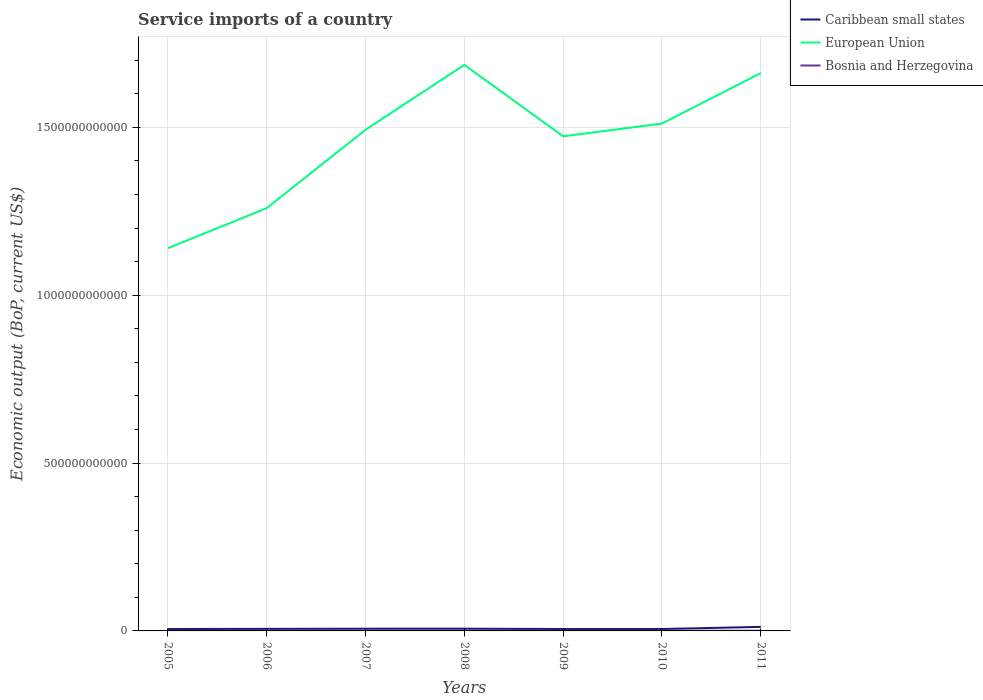How many different coloured lines are there?
Offer a very short reply. 3. Does the line corresponding to European Union intersect with the line corresponding to Caribbean small states?
Your answer should be very brief. No. Across all years, what is the maximum service imports in Caribbean small states?
Ensure brevity in your answer.  5.64e+09. In which year was the service imports in Caribbean small states maximum?
Make the answer very short. 2005. What is the total service imports in Caribbean small states in the graph?
Provide a short and direct response. -9.07e+08. What is the difference between the highest and the second highest service imports in Caribbean small states?
Your answer should be very brief. 6.39e+09. What is the difference between the highest and the lowest service imports in Caribbean small states?
Offer a terse response. 1. What is the difference between two consecutive major ticks on the Y-axis?
Give a very brief answer. 5.00e+11. Are the values on the major ticks of Y-axis written in scientific E-notation?
Offer a very short reply. No. Does the graph contain any zero values?
Your answer should be compact. No. Does the graph contain grids?
Your answer should be very brief. Yes. Where does the legend appear in the graph?
Offer a very short reply. Top right. How are the legend labels stacked?
Offer a terse response. Vertical. What is the title of the graph?
Give a very brief answer. Service imports of a country. What is the label or title of the X-axis?
Give a very brief answer. Years. What is the label or title of the Y-axis?
Your answer should be very brief. Economic output (BoP, current US$). What is the Economic output (BoP, current US$) of Caribbean small states in 2005?
Provide a succinct answer. 5.64e+09. What is the Economic output (BoP, current US$) in European Union in 2005?
Keep it short and to the point. 1.14e+12. What is the Economic output (BoP, current US$) in Bosnia and Herzegovina in 2005?
Offer a terse response. 4.36e+08. What is the Economic output (BoP, current US$) in Caribbean small states in 2006?
Make the answer very short. 6.14e+09. What is the Economic output (BoP, current US$) in European Union in 2006?
Give a very brief answer. 1.26e+12. What is the Economic output (BoP, current US$) of Bosnia and Herzegovina in 2006?
Make the answer very short. 4.67e+08. What is the Economic output (BoP, current US$) in Caribbean small states in 2007?
Your answer should be compact. 6.55e+09. What is the Economic output (BoP, current US$) of European Union in 2007?
Make the answer very short. 1.49e+12. What is the Economic output (BoP, current US$) of Bosnia and Herzegovina in 2007?
Give a very brief answer. 4.95e+08. What is the Economic output (BoP, current US$) of Caribbean small states in 2008?
Offer a terse response. 6.66e+09. What is the Economic output (BoP, current US$) in European Union in 2008?
Give a very brief answer. 1.69e+12. What is the Economic output (BoP, current US$) in Bosnia and Herzegovina in 2008?
Provide a succinct answer. 5.95e+08. What is the Economic output (BoP, current US$) of Caribbean small states in 2009?
Make the answer very short. 5.67e+09. What is the Economic output (BoP, current US$) in European Union in 2009?
Provide a succinct answer. 1.47e+12. What is the Economic output (BoP, current US$) of Bosnia and Herzegovina in 2009?
Make the answer very short. 6.40e+08. What is the Economic output (BoP, current US$) of Caribbean small states in 2010?
Keep it short and to the point. 5.69e+09. What is the Economic output (BoP, current US$) in European Union in 2010?
Offer a terse response. 1.51e+12. What is the Economic output (BoP, current US$) of Bosnia and Herzegovina in 2010?
Keep it short and to the point. 5.41e+08. What is the Economic output (BoP, current US$) of Caribbean small states in 2011?
Make the answer very short. 1.20e+1. What is the Economic output (BoP, current US$) of European Union in 2011?
Make the answer very short. 1.66e+12. What is the Economic output (BoP, current US$) in Bosnia and Herzegovina in 2011?
Give a very brief answer. 5.57e+08. Across all years, what is the maximum Economic output (BoP, current US$) in Caribbean small states?
Your response must be concise. 1.20e+1. Across all years, what is the maximum Economic output (BoP, current US$) of European Union?
Keep it short and to the point. 1.69e+12. Across all years, what is the maximum Economic output (BoP, current US$) of Bosnia and Herzegovina?
Offer a very short reply. 6.40e+08. Across all years, what is the minimum Economic output (BoP, current US$) of Caribbean small states?
Provide a succinct answer. 5.64e+09. Across all years, what is the minimum Economic output (BoP, current US$) in European Union?
Your answer should be very brief. 1.14e+12. Across all years, what is the minimum Economic output (BoP, current US$) in Bosnia and Herzegovina?
Give a very brief answer. 4.36e+08. What is the total Economic output (BoP, current US$) of Caribbean small states in the graph?
Your response must be concise. 4.84e+1. What is the total Economic output (BoP, current US$) in European Union in the graph?
Offer a terse response. 1.02e+13. What is the total Economic output (BoP, current US$) of Bosnia and Herzegovina in the graph?
Make the answer very short. 3.73e+09. What is the difference between the Economic output (BoP, current US$) of Caribbean small states in 2005 and that in 2006?
Offer a terse response. -5.00e+08. What is the difference between the Economic output (BoP, current US$) of European Union in 2005 and that in 2006?
Give a very brief answer. -1.19e+11. What is the difference between the Economic output (BoP, current US$) of Bosnia and Herzegovina in 2005 and that in 2006?
Give a very brief answer. -3.12e+07. What is the difference between the Economic output (BoP, current US$) in Caribbean small states in 2005 and that in 2007?
Give a very brief answer. -9.07e+08. What is the difference between the Economic output (BoP, current US$) of European Union in 2005 and that in 2007?
Ensure brevity in your answer.  -3.53e+11. What is the difference between the Economic output (BoP, current US$) of Bosnia and Herzegovina in 2005 and that in 2007?
Offer a terse response. -5.97e+07. What is the difference between the Economic output (BoP, current US$) of Caribbean small states in 2005 and that in 2008?
Provide a succinct answer. -1.02e+09. What is the difference between the Economic output (BoP, current US$) of European Union in 2005 and that in 2008?
Provide a short and direct response. -5.46e+11. What is the difference between the Economic output (BoP, current US$) in Bosnia and Herzegovina in 2005 and that in 2008?
Offer a terse response. -1.59e+08. What is the difference between the Economic output (BoP, current US$) in Caribbean small states in 2005 and that in 2009?
Offer a very short reply. -2.25e+07. What is the difference between the Economic output (BoP, current US$) of European Union in 2005 and that in 2009?
Give a very brief answer. -3.33e+11. What is the difference between the Economic output (BoP, current US$) of Bosnia and Herzegovina in 2005 and that in 2009?
Give a very brief answer. -2.05e+08. What is the difference between the Economic output (BoP, current US$) of Caribbean small states in 2005 and that in 2010?
Offer a terse response. -4.30e+07. What is the difference between the Economic output (BoP, current US$) in European Union in 2005 and that in 2010?
Your answer should be compact. -3.71e+11. What is the difference between the Economic output (BoP, current US$) in Bosnia and Herzegovina in 2005 and that in 2010?
Make the answer very short. -1.05e+08. What is the difference between the Economic output (BoP, current US$) of Caribbean small states in 2005 and that in 2011?
Offer a very short reply. -6.39e+09. What is the difference between the Economic output (BoP, current US$) of European Union in 2005 and that in 2011?
Provide a short and direct response. -5.22e+11. What is the difference between the Economic output (BoP, current US$) of Bosnia and Herzegovina in 2005 and that in 2011?
Make the answer very short. -1.22e+08. What is the difference between the Economic output (BoP, current US$) in Caribbean small states in 2006 and that in 2007?
Give a very brief answer. -4.07e+08. What is the difference between the Economic output (BoP, current US$) in European Union in 2006 and that in 2007?
Make the answer very short. -2.33e+11. What is the difference between the Economic output (BoP, current US$) in Bosnia and Herzegovina in 2006 and that in 2007?
Keep it short and to the point. -2.86e+07. What is the difference between the Economic output (BoP, current US$) of Caribbean small states in 2006 and that in 2008?
Make the answer very short. -5.19e+08. What is the difference between the Economic output (BoP, current US$) of European Union in 2006 and that in 2008?
Keep it short and to the point. -4.27e+11. What is the difference between the Economic output (BoP, current US$) in Bosnia and Herzegovina in 2006 and that in 2008?
Your response must be concise. -1.28e+08. What is the difference between the Economic output (BoP, current US$) in Caribbean small states in 2006 and that in 2009?
Keep it short and to the point. 4.78e+08. What is the difference between the Economic output (BoP, current US$) of European Union in 2006 and that in 2009?
Make the answer very short. -2.14e+11. What is the difference between the Economic output (BoP, current US$) in Bosnia and Herzegovina in 2006 and that in 2009?
Ensure brevity in your answer.  -1.74e+08. What is the difference between the Economic output (BoP, current US$) in Caribbean small states in 2006 and that in 2010?
Make the answer very short. 4.57e+08. What is the difference between the Economic output (BoP, current US$) in European Union in 2006 and that in 2010?
Provide a succinct answer. -2.52e+11. What is the difference between the Economic output (BoP, current US$) of Bosnia and Herzegovina in 2006 and that in 2010?
Offer a terse response. -7.42e+07. What is the difference between the Economic output (BoP, current US$) in Caribbean small states in 2006 and that in 2011?
Your answer should be very brief. -5.89e+09. What is the difference between the Economic output (BoP, current US$) in European Union in 2006 and that in 2011?
Offer a very short reply. -4.02e+11. What is the difference between the Economic output (BoP, current US$) of Bosnia and Herzegovina in 2006 and that in 2011?
Your answer should be very brief. -9.05e+07. What is the difference between the Economic output (BoP, current US$) in Caribbean small states in 2007 and that in 2008?
Give a very brief answer. -1.12e+08. What is the difference between the Economic output (BoP, current US$) of European Union in 2007 and that in 2008?
Your answer should be very brief. -1.93e+11. What is the difference between the Economic output (BoP, current US$) of Bosnia and Herzegovina in 2007 and that in 2008?
Offer a very short reply. -9.97e+07. What is the difference between the Economic output (BoP, current US$) of Caribbean small states in 2007 and that in 2009?
Make the answer very short. 8.85e+08. What is the difference between the Economic output (BoP, current US$) in European Union in 2007 and that in 2009?
Your answer should be compact. 1.95e+1. What is the difference between the Economic output (BoP, current US$) in Bosnia and Herzegovina in 2007 and that in 2009?
Your answer should be very brief. -1.45e+08. What is the difference between the Economic output (BoP, current US$) of Caribbean small states in 2007 and that in 2010?
Provide a succinct answer. 8.64e+08. What is the difference between the Economic output (BoP, current US$) in European Union in 2007 and that in 2010?
Your answer should be compact. -1.86e+1. What is the difference between the Economic output (BoP, current US$) in Bosnia and Herzegovina in 2007 and that in 2010?
Provide a succinct answer. -4.56e+07. What is the difference between the Economic output (BoP, current US$) of Caribbean small states in 2007 and that in 2011?
Offer a very short reply. -5.48e+09. What is the difference between the Economic output (BoP, current US$) of European Union in 2007 and that in 2011?
Provide a succinct answer. -1.69e+11. What is the difference between the Economic output (BoP, current US$) of Bosnia and Herzegovina in 2007 and that in 2011?
Give a very brief answer. -6.19e+07. What is the difference between the Economic output (BoP, current US$) in Caribbean small states in 2008 and that in 2009?
Offer a terse response. 9.96e+08. What is the difference between the Economic output (BoP, current US$) in European Union in 2008 and that in 2009?
Ensure brevity in your answer.  2.13e+11. What is the difference between the Economic output (BoP, current US$) of Bosnia and Herzegovina in 2008 and that in 2009?
Offer a very short reply. -4.55e+07. What is the difference between the Economic output (BoP, current US$) of Caribbean small states in 2008 and that in 2010?
Provide a succinct answer. 9.76e+08. What is the difference between the Economic output (BoP, current US$) in European Union in 2008 and that in 2010?
Offer a terse response. 1.75e+11. What is the difference between the Economic output (BoP, current US$) of Bosnia and Herzegovina in 2008 and that in 2010?
Ensure brevity in your answer.  5.40e+07. What is the difference between the Economic output (BoP, current US$) in Caribbean small states in 2008 and that in 2011?
Your answer should be compact. -5.37e+09. What is the difference between the Economic output (BoP, current US$) of European Union in 2008 and that in 2011?
Keep it short and to the point. 2.44e+1. What is the difference between the Economic output (BoP, current US$) of Bosnia and Herzegovina in 2008 and that in 2011?
Ensure brevity in your answer.  3.77e+07. What is the difference between the Economic output (BoP, current US$) of Caribbean small states in 2009 and that in 2010?
Offer a very short reply. -2.06e+07. What is the difference between the Economic output (BoP, current US$) of European Union in 2009 and that in 2010?
Provide a short and direct response. -3.81e+1. What is the difference between the Economic output (BoP, current US$) of Bosnia and Herzegovina in 2009 and that in 2010?
Keep it short and to the point. 9.95e+07. What is the difference between the Economic output (BoP, current US$) in Caribbean small states in 2009 and that in 2011?
Ensure brevity in your answer.  -6.37e+09. What is the difference between the Economic output (BoP, current US$) in European Union in 2009 and that in 2011?
Offer a very short reply. -1.88e+11. What is the difference between the Economic output (BoP, current US$) in Bosnia and Herzegovina in 2009 and that in 2011?
Your response must be concise. 8.32e+07. What is the difference between the Economic output (BoP, current US$) of Caribbean small states in 2010 and that in 2011?
Provide a short and direct response. -6.35e+09. What is the difference between the Economic output (BoP, current US$) of European Union in 2010 and that in 2011?
Give a very brief answer. -1.50e+11. What is the difference between the Economic output (BoP, current US$) of Bosnia and Herzegovina in 2010 and that in 2011?
Your response must be concise. -1.63e+07. What is the difference between the Economic output (BoP, current US$) in Caribbean small states in 2005 and the Economic output (BoP, current US$) in European Union in 2006?
Give a very brief answer. -1.25e+12. What is the difference between the Economic output (BoP, current US$) of Caribbean small states in 2005 and the Economic output (BoP, current US$) of Bosnia and Herzegovina in 2006?
Keep it short and to the point. 5.18e+09. What is the difference between the Economic output (BoP, current US$) in European Union in 2005 and the Economic output (BoP, current US$) in Bosnia and Herzegovina in 2006?
Offer a very short reply. 1.14e+12. What is the difference between the Economic output (BoP, current US$) of Caribbean small states in 2005 and the Economic output (BoP, current US$) of European Union in 2007?
Offer a terse response. -1.49e+12. What is the difference between the Economic output (BoP, current US$) of Caribbean small states in 2005 and the Economic output (BoP, current US$) of Bosnia and Herzegovina in 2007?
Ensure brevity in your answer.  5.15e+09. What is the difference between the Economic output (BoP, current US$) of European Union in 2005 and the Economic output (BoP, current US$) of Bosnia and Herzegovina in 2007?
Provide a short and direct response. 1.14e+12. What is the difference between the Economic output (BoP, current US$) of Caribbean small states in 2005 and the Economic output (BoP, current US$) of European Union in 2008?
Offer a terse response. -1.68e+12. What is the difference between the Economic output (BoP, current US$) of Caribbean small states in 2005 and the Economic output (BoP, current US$) of Bosnia and Herzegovina in 2008?
Keep it short and to the point. 5.05e+09. What is the difference between the Economic output (BoP, current US$) of European Union in 2005 and the Economic output (BoP, current US$) of Bosnia and Herzegovina in 2008?
Offer a very short reply. 1.14e+12. What is the difference between the Economic output (BoP, current US$) of Caribbean small states in 2005 and the Economic output (BoP, current US$) of European Union in 2009?
Your answer should be compact. -1.47e+12. What is the difference between the Economic output (BoP, current US$) in Caribbean small states in 2005 and the Economic output (BoP, current US$) in Bosnia and Herzegovina in 2009?
Provide a succinct answer. 5.00e+09. What is the difference between the Economic output (BoP, current US$) of European Union in 2005 and the Economic output (BoP, current US$) of Bosnia and Herzegovina in 2009?
Your answer should be compact. 1.14e+12. What is the difference between the Economic output (BoP, current US$) of Caribbean small states in 2005 and the Economic output (BoP, current US$) of European Union in 2010?
Ensure brevity in your answer.  -1.51e+12. What is the difference between the Economic output (BoP, current US$) in Caribbean small states in 2005 and the Economic output (BoP, current US$) in Bosnia and Herzegovina in 2010?
Keep it short and to the point. 5.10e+09. What is the difference between the Economic output (BoP, current US$) in European Union in 2005 and the Economic output (BoP, current US$) in Bosnia and Herzegovina in 2010?
Provide a succinct answer. 1.14e+12. What is the difference between the Economic output (BoP, current US$) in Caribbean small states in 2005 and the Economic output (BoP, current US$) in European Union in 2011?
Offer a very short reply. -1.66e+12. What is the difference between the Economic output (BoP, current US$) in Caribbean small states in 2005 and the Economic output (BoP, current US$) in Bosnia and Herzegovina in 2011?
Provide a succinct answer. 5.09e+09. What is the difference between the Economic output (BoP, current US$) in European Union in 2005 and the Economic output (BoP, current US$) in Bosnia and Herzegovina in 2011?
Keep it short and to the point. 1.14e+12. What is the difference between the Economic output (BoP, current US$) in Caribbean small states in 2006 and the Economic output (BoP, current US$) in European Union in 2007?
Make the answer very short. -1.49e+12. What is the difference between the Economic output (BoP, current US$) of Caribbean small states in 2006 and the Economic output (BoP, current US$) of Bosnia and Herzegovina in 2007?
Make the answer very short. 5.65e+09. What is the difference between the Economic output (BoP, current US$) of European Union in 2006 and the Economic output (BoP, current US$) of Bosnia and Herzegovina in 2007?
Offer a terse response. 1.26e+12. What is the difference between the Economic output (BoP, current US$) of Caribbean small states in 2006 and the Economic output (BoP, current US$) of European Union in 2008?
Your answer should be very brief. -1.68e+12. What is the difference between the Economic output (BoP, current US$) in Caribbean small states in 2006 and the Economic output (BoP, current US$) in Bosnia and Herzegovina in 2008?
Your response must be concise. 5.55e+09. What is the difference between the Economic output (BoP, current US$) in European Union in 2006 and the Economic output (BoP, current US$) in Bosnia and Herzegovina in 2008?
Provide a short and direct response. 1.26e+12. What is the difference between the Economic output (BoP, current US$) of Caribbean small states in 2006 and the Economic output (BoP, current US$) of European Union in 2009?
Your response must be concise. -1.47e+12. What is the difference between the Economic output (BoP, current US$) of Caribbean small states in 2006 and the Economic output (BoP, current US$) of Bosnia and Herzegovina in 2009?
Make the answer very short. 5.50e+09. What is the difference between the Economic output (BoP, current US$) of European Union in 2006 and the Economic output (BoP, current US$) of Bosnia and Herzegovina in 2009?
Give a very brief answer. 1.26e+12. What is the difference between the Economic output (BoP, current US$) of Caribbean small states in 2006 and the Economic output (BoP, current US$) of European Union in 2010?
Your answer should be very brief. -1.51e+12. What is the difference between the Economic output (BoP, current US$) in Caribbean small states in 2006 and the Economic output (BoP, current US$) in Bosnia and Herzegovina in 2010?
Your response must be concise. 5.60e+09. What is the difference between the Economic output (BoP, current US$) in European Union in 2006 and the Economic output (BoP, current US$) in Bosnia and Herzegovina in 2010?
Your answer should be compact. 1.26e+12. What is the difference between the Economic output (BoP, current US$) of Caribbean small states in 2006 and the Economic output (BoP, current US$) of European Union in 2011?
Provide a short and direct response. -1.66e+12. What is the difference between the Economic output (BoP, current US$) in Caribbean small states in 2006 and the Economic output (BoP, current US$) in Bosnia and Herzegovina in 2011?
Ensure brevity in your answer.  5.59e+09. What is the difference between the Economic output (BoP, current US$) of European Union in 2006 and the Economic output (BoP, current US$) of Bosnia and Herzegovina in 2011?
Offer a terse response. 1.26e+12. What is the difference between the Economic output (BoP, current US$) of Caribbean small states in 2007 and the Economic output (BoP, current US$) of European Union in 2008?
Provide a short and direct response. -1.68e+12. What is the difference between the Economic output (BoP, current US$) in Caribbean small states in 2007 and the Economic output (BoP, current US$) in Bosnia and Herzegovina in 2008?
Your answer should be compact. 5.96e+09. What is the difference between the Economic output (BoP, current US$) of European Union in 2007 and the Economic output (BoP, current US$) of Bosnia and Herzegovina in 2008?
Offer a very short reply. 1.49e+12. What is the difference between the Economic output (BoP, current US$) of Caribbean small states in 2007 and the Economic output (BoP, current US$) of European Union in 2009?
Offer a terse response. -1.47e+12. What is the difference between the Economic output (BoP, current US$) of Caribbean small states in 2007 and the Economic output (BoP, current US$) of Bosnia and Herzegovina in 2009?
Keep it short and to the point. 5.91e+09. What is the difference between the Economic output (BoP, current US$) in European Union in 2007 and the Economic output (BoP, current US$) in Bosnia and Herzegovina in 2009?
Keep it short and to the point. 1.49e+12. What is the difference between the Economic output (BoP, current US$) of Caribbean small states in 2007 and the Economic output (BoP, current US$) of European Union in 2010?
Your answer should be compact. -1.50e+12. What is the difference between the Economic output (BoP, current US$) of Caribbean small states in 2007 and the Economic output (BoP, current US$) of Bosnia and Herzegovina in 2010?
Your response must be concise. 6.01e+09. What is the difference between the Economic output (BoP, current US$) of European Union in 2007 and the Economic output (BoP, current US$) of Bosnia and Herzegovina in 2010?
Offer a very short reply. 1.49e+12. What is the difference between the Economic output (BoP, current US$) in Caribbean small states in 2007 and the Economic output (BoP, current US$) in European Union in 2011?
Your answer should be compact. -1.66e+12. What is the difference between the Economic output (BoP, current US$) in Caribbean small states in 2007 and the Economic output (BoP, current US$) in Bosnia and Herzegovina in 2011?
Offer a terse response. 5.99e+09. What is the difference between the Economic output (BoP, current US$) of European Union in 2007 and the Economic output (BoP, current US$) of Bosnia and Herzegovina in 2011?
Your answer should be compact. 1.49e+12. What is the difference between the Economic output (BoP, current US$) in Caribbean small states in 2008 and the Economic output (BoP, current US$) in European Union in 2009?
Your answer should be compact. -1.47e+12. What is the difference between the Economic output (BoP, current US$) in Caribbean small states in 2008 and the Economic output (BoP, current US$) in Bosnia and Herzegovina in 2009?
Provide a short and direct response. 6.02e+09. What is the difference between the Economic output (BoP, current US$) of European Union in 2008 and the Economic output (BoP, current US$) of Bosnia and Herzegovina in 2009?
Provide a succinct answer. 1.69e+12. What is the difference between the Economic output (BoP, current US$) in Caribbean small states in 2008 and the Economic output (BoP, current US$) in European Union in 2010?
Your response must be concise. -1.50e+12. What is the difference between the Economic output (BoP, current US$) in Caribbean small states in 2008 and the Economic output (BoP, current US$) in Bosnia and Herzegovina in 2010?
Give a very brief answer. 6.12e+09. What is the difference between the Economic output (BoP, current US$) in European Union in 2008 and the Economic output (BoP, current US$) in Bosnia and Herzegovina in 2010?
Offer a very short reply. 1.69e+12. What is the difference between the Economic output (BoP, current US$) of Caribbean small states in 2008 and the Economic output (BoP, current US$) of European Union in 2011?
Provide a short and direct response. -1.66e+12. What is the difference between the Economic output (BoP, current US$) of Caribbean small states in 2008 and the Economic output (BoP, current US$) of Bosnia and Herzegovina in 2011?
Your answer should be very brief. 6.11e+09. What is the difference between the Economic output (BoP, current US$) in European Union in 2008 and the Economic output (BoP, current US$) in Bosnia and Herzegovina in 2011?
Ensure brevity in your answer.  1.69e+12. What is the difference between the Economic output (BoP, current US$) in Caribbean small states in 2009 and the Economic output (BoP, current US$) in European Union in 2010?
Ensure brevity in your answer.  -1.51e+12. What is the difference between the Economic output (BoP, current US$) in Caribbean small states in 2009 and the Economic output (BoP, current US$) in Bosnia and Herzegovina in 2010?
Keep it short and to the point. 5.13e+09. What is the difference between the Economic output (BoP, current US$) of European Union in 2009 and the Economic output (BoP, current US$) of Bosnia and Herzegovina in 2010?
Your response must be concise. 1.47e+12. What is the difference between the Economic output (BoP, current US$) in Caribbean small states in 2009 and the Economic output (BoP, current US$) in European Union in 2011?
Ensure brevity in your answer.  -1.66e+12. What is the difference between the Economic output (BoP, current US$) of Caribbean small states in 2009 and the Economic output (BoP, current US$) of Bosnia and Herzegovina in 2011?
Your answer should be very brief. 5.11e+09. What is the difference between the Economic output (BoP, current US$) in European Union in 2009 and the Economic output (BoP, current US$) in Bosnia and Herzegovina in 2011?
Your response must be concise. 1.47e+12. What is the difference between the Economic output (BoP, current US$) in Caribbean small states in 2010 and the Economic output (BoP, current US$) in European Union in 2011?
Give a very brief answer. -1.66e+12. What is the difference between the Economic output (BoP, current US$) of Caribbean small states in 2010 and the Economic output (BoP, current US$) of Bosnia and Herzegovina in 2011?
Your answer should be compact. 5.13e+09. What is the difference between the Economic output (BoP, current US$) of European Union in 2010 and the Economic output (BoP, current US$) of Bosnia and Herzegovina in 2011?
Ensure brevity in your answer.  1.51e+12. What is the average Economic output (BoP, current US$) in Caribbean small states per year?
Ensure brevity in your answer.  6.91e+09. What is the average Economic output (BoP, current US$) of European Union per year?
Provide a short and direct response. 1.46e+12. What is the average Economic output (BoP, current US$) in Bosnia and Herzegovina per year?
Give a very brief answer. 5.33e+08. In the year 2005, what is the difference between the Economic output (BoP, current US$) of Caribbean small states and Economic output (BoP, current US$) of European Union?
Provide a short and direct response. -1.13e+12. In the year 2005, what is the difference between the Economic output (BoP, current US$) in Caribbean small states and Economic output (BoP, current US$) in Bosnia and Herzegovina?
Ensure brevity in your answer.  5.21e+09. In the year 2005, what is the difference between the Economic output (BoP, current US$) of European Union and Economic output (BoP, current US$) of Bosnia and Herzegovina?
Offer a terse response. 1.14e+12. In the year 2006, what is the difference between the Economic output (BoP, current US$) of Caribbean small states and Economic output (BoP, current US$) of European Union?
Provide a short and direct response. -1.25e+12. In the year 2006, what is the difference between the Economic output (BoP, current US$) in Caribbean small states and Economic output (BoP, current US$) in Bosnia and Herzegovina?
Offer a very short reply. 5.68e+09. In the year 2006, what is the difference between the Economic output (BoP, current US$) in European Union and Economic output (BoP, current US$) in Bosnia and Herzegovina?
Provide a succinct answer. 1.26e+12. In the year 2007, what is the difference between the Economic output (BoP, current US$) in Caribbean small states and Economic output (BoP, current US$) in European Union?
Provide a short and direct response. -1.49e+12. In the year 2007, what is the difference between the Economic output (BoP, current US$) in Caribbean small states and Economic output (BoP, current US$) in Bosnia and Herzegovina?
Keep it short and to the point. 6.06e+09. In the year 2007, what is the difference between the Economic output (BoP, current US$) of European Union and Economic output (BoP, current US$) of Bosnia and Herzegovina?
Offer a terse response. 1.49e+12. In the year 2008, what is the difference between the Economic output (BoP, current US$) in Caribbean small states and Economic output (BoP, current US$) in European Union?
Your response must be concise. -1.68e+12. In the year 2008, what is the difference between the Economic output (BoP, current US$) in Caribbean small states and Economic output (BoP, current US$) in Bosnia and Herzegovina?
Keep it short and to the point. 6.07e+09. In the year 2008, what is the difference between the Economic output (BoP, current US$) in European Union and Economic output (BoP, current US$) in Bosnia and Herzegovina?
Provide a succinct answer. 1.69e+12. In the year 2009, what is the difference between the Economic output (BoP, current US$) in Caribbean small states and Economic output (BoP, current US$) in European Union?
Make the answer very short. -1.47e+12. In the year 2009, what is the difference between the Economic output (BoP, current US$) in Caribbean small states and Economic output (BoP, current US$) in Bosnia and Herzegovina?
Make the answer very short. 5.03e+09. In the year 2009, what is the difference between the Economic output (BoP, current US$) in European Union and Economic output (BoP, current US$) in Bosnia and Herzegovina?
Keep it short and to the point. 1.47e+12. In the year 2010, what is the difference between the Economic output (BoP, current US$) in Caribbean small states and Economic output (BoP, current US$) in European Union?
Ensure brevity in your answer.  -1.51e+12. In the year 2010, what is the difference between the Economic output (BoP, current US$) in Caribbean small states and Economic output (BoP, current US$) in Bosnia and Herzegovina?
Give a very brief answer. 5.15e+09. In the year 2010, what is the difference between the Economic output (BoP, current US$) in European Union and Economic output (BoP, current US$) in Bosnia and Herzegovina?
Provide a short and direct response. 1.51e+12. In the year 2011, what is the difference between the Economic output (BoP, current US$) of Caribbean small states and Economic output (BoP, current US$) of European Union?
Your answer should be very brief. -1.65e+12. In the year 2011, what is the difference between the Economic output (BoP, current US$) of Caribbean small states and Economic output (BoP, current US$) of Bosnia and Herzegovina?
Offer a terse response. 1.15e+1. In the year 2011, what is the difference between the Economic output (BoP, current US$) in European Union and Economic output (BoP, current US$) in Bosnia and Herzegovina?
Keep it short and to the point. 1.66e+12. What is the ratio of the Economic output (BoP, current US$) of Caribbean small states in 2005 to that in 2006?
Make the answer very short. 0.92. What is the ratio of the Economic output (BoP, current US$) of European Union in 2005 to that in 2006?
Give a very brief answer. 0.91. What is the ratio of the Economic output (BoP, current US$) of Bosnia and Herzegovina in 2005 to that in 2006?
Ensure brevity in your answer.  0.93. What is the ratio of the Economic output (BoP, current US$) in Caribbean small states in 2005 to that in 2007?
Ensure brevity in your answer.  0.86. What is the ratio of the Economic output (BoP, current US$) in European Union in 2005 to that in 2007?
Your answer should be very brief. 0.76. What is the ratio of the Economic output (BoP, current US$) of Bosnia and Herzegovina in 2005 to that in 2007?
Ensure brevity in your answer.  0.88. What is the ratio of the Economic output (BoP, current US$) in Caribbean small states in 2005 to that in 2008?
Make the answer very short. 0.85. What is the ratio of the Economic output (BoP, current US$) in European Union in 2005 to that in 2008?
Ensure brevity in your answer.  0.68. What is the ratio of the Economic output (BoP, current US$) of Bosnia and Herzegovina in 2005 to that in 2008?
Keep it short and to the point. 0.73. What is the ratio of the Economic output (BoP, current US$) of Caribbean small states in 2005 to that in 2009?
Your answer should be compact. 1. What is the ratio of the Economic output (BoP, current US$) of European Union in 2005 to that in 2009?
Make the answer very short. 0.77. What is the ratio of the Economic output (BoP, current US$) of Bosnia and Herzegovina in 2005 to that in 2009?
Keep it short and to the point. 0.68. What is the ratio of the Economic output (BoP, current US$) in European Union in 2005 to that in 2010?
Offer a terse response. 0.75. What is the ratio of the Economic output (BoP, current US$) in Bosnia and Herzegovina in 2005 to that in 2010?
Provide a succinct answer. 0.81. What is the ratio of the Economic output (BoP, current US$) of Caribbean small states in 2005 to that in 2011?
Your answer should be very brief. 0.47. What is the ratio of the Economic output (BoP, current US$) of European Union in 2005 to that in 2011?
Your response must be concise. 0.69. What is the ratio of the Economic output (BoP, current US$) in Bosnia and Herzegovina in 2005 to that in 2011?
Give a very brief answer. 0.78. What is the ratio of the Economic output (BoP, current US$) in Caribbean small states in 2006 to that in 2007?
Your answer should be compact. 0.94. What is the ratio of the Economic output (BoP, current US$) in European Union in 2006 to that in 2007?
Your answer should be compact. 0.84. What is the ratio of the Economic output (BoP, current US$) of Bosnia and Herzegovina in 2006 to that in 2007?
Give a very brief answer. 0.94. What is the ratio of the Economic output (BoP, current US$) of Caribbean small states in 2006 to that in 2008?
Give a very brief answer. 0.92. What is the ratio of the Economic output (BoP, current US$) in European Union in 2006 to that in 2008?
Your answer should be compact. 0.75. What is the ratio of the Economic output (BoP, current US$) of Bosnia and Herzegovina in 2006 to that in 2008?
Provide a succinct answer. 0.78. What is the ratio of the Economic output (BoP, current US$) in Caribbean small states in 2006 to that in 2009?
Give a very brief answer. 1.08. What is the ratio of the Economic output (BoP, current US$) in European Union in 2006 to that in 2009?
Offer a terse response. 0.85. What is the ratio of the Economic output (BoP, current US$) of Bosnia and Herzegovina in 2006 to that in 2009?
Ensure brevity in your answer.  0.73. What is the ratio of the Economic output (BoP, current US$) of Caribbean small states in 2006 to that in 2010?
Offer a very short reply. 1.08. What is the ratio of the Economic output (BoP, current US$) in European Union in 2006 to that in 2010?
Ensure brevity in your answer.  0.83. What is the ratio of the Economic output (BoP, current US$) in Bosnia and Herzegovina in 2006 to that in 2010?
Make the answer very short. 0.86. What is the ratio of the Economic output (BoP, current US$) in Caribbean small states in 2006 to that in 2011?
Your answer should be compact. 0.51. What is the ratio of the Economic output (BoP, current US$) in European Union in 2006 to that in 2011?
Provide a short and direct response. 0.76. What is the ratio of the Economic output (BoP, current US$) in Bosnia and Herzegovina in 2006 to that in 2011?
Make the answer very short. 0.84. What is the ratio of the Economic output (BoP, current US$) of Caribbean small states in 2007 to that in 2008?
Provide a short and direct response. 0.98. What is the ratio of the Economic output (BoP, current US$) in European Union in 2007 to that in 2008?
Your answer should be very brief. 0.89. What is the ratio of the Economic output (BoP, current US$) of Bosnia and Herzegovina in 2007 to that in 2008?
Your answer should be very brief. 0.83. What is the ratio of the Economic output (BoP, current US$) in Caribbean small states in 2007 to that in 2009?
Provide a succinct answer. 1.16. What is the ratio of the Economic output (BoP, current US$) of European Union in 2007 to that in 2009?
Provide a short and direct response. 1.01. What is the ratio of the Economic output (BoP, current US$) of Bosnia and Herzegovina in 2007 to that in 2009?
Your answer should be compact. 0.77. What is the ratio of the Economic output (BoP, current US$) in Caribbean small states in 2007 to that in 2010?
Provide a succinct answer. 1.15. What is the ratio of the Economic output (BoP, current US$) of European Union in 2007 to that in 2010?
Your answer should be compact. 0.99. What is the ratio of the Economic output (BoP, current US$) of Bosnia and Herzegovina in 2007 to that in 2010?
Your answer should be compact. 0.92. What is the ratio of the Economic output (BoP, current US$) in Caribbean small states in 2007 to that in 2011?
Your response must be concise. 0.54. What is the ratio of the Economic output (BoP, current US$) of European Union in 2007 to that in 2011?
Offer a terse response. 0.9. What is the ratio of the Economic output (BoP, current US$) in Caribbean small states in 2008 to that in 2009?
Provide a succinct answer. 1.18. What is the ratio of the Economic output (BoP, current US$) of European Union in 2008 to that in 2009?
Offer a very short reply. 1.14. What is the ratio of the Economic output (BoP, current US$) of Bosnia and Herzegovina in 2008 to that in 2009?
Provide a succinct answer. 0.93. What is the ratio of the Economic output (BoP, current US$) of Caribbean small states in 2008 to that in 2010?
Give a very brief answer. 1.17. What is the ratio of the Economic output (BoP, current US$) of European Union in 2008 to that in 2010?
Make the answer very short. 1.12. What is the ratio of the Economic output (BoP, current US$) in Bosnia and Herzegovina in 2008 to that in 2010?
Offer a terse response. 1.1. What is the ratio of the Economic output (BoP, current US$) in Caribbean small states in 2008 to that in 2011?
Make the answer very short. 0.55. What is the ratio of the Economic output (BoP, current US$) in European Union in 2008 to that in 2011?
Provide a short and direct response. 1.01. What is the ratio of the Economic output (BoP, current US$) in Bosnia and Herzegovina in 2008 to that in 2011?
Offer a very short reply. 1.07. What is the ratio of the Economic output (BoP, current US$) in European Union in 2009 to that in 2010?
Offer a terse response. 0.97. What is the ratio of the Economic output (BoP, current US$) of Bosnia and Herzegovina in 2009 to that in 2010?
Offer a terse response. 1.18. What is the ratio of the Economic output (BoP, current US$) of Caribbean small states in 2009 to that in 2011?
Your response must be concise. 0.47. What is the ratio of the Economic output (BoP, current US$) in European Union in 2009 to that in 2011?
Provide a succinct answer. 0.89. What is the ratio of the Economic output (BoP, current US$) in Bosnia and Herzegovina in 2009 to that in 2011?
Your answer should be compact. 1.15. What is the ratio of the Economic output (BoP, current US$) of Caribbean small states in 2010 to that in 2011?
Your answer should be compact. 0.47. What is the ratio of the Economic output (BoP, current US$) in European Union in 2010 to that in 2011?
Keep it short and to the point. 0.91. What is the ratio of the Economic output (BoP, current US$) in Bosnia and Herzegovina in 2010 to that in 2011?
Offer a terse response. 0.97. What is the difference between the highest and the second highest Economic output (BoP, current US$) of Caribbean small states?
Keep it short and to the point. 5.37e+09. What is the difference between the highest and the second highest Economic output (BoP, current US$) of European Union?
Offer a very short reply. 2.44e+1. What is the difference between the highest and the second highest Economic output (BoP, current US$) in Bosnia and Herzegovina?
Ensure brevity in your answer.  4.55e+07. What is the difference between the highest and the lowest Economic output (BoP, current US$) in Caribbean small states?
Your answer should be very brief. 6.39e+09. What is the difference between the highest and the lowest Economic output (BoP, current US$) of European Union?
Provide a short and direct response. 5.46e+11. What is the difference between the highest and the lowest Economic output (BoP, current US$) in Bosnia and Herzegovina?
Make the answer very short. 2.05e+08. 